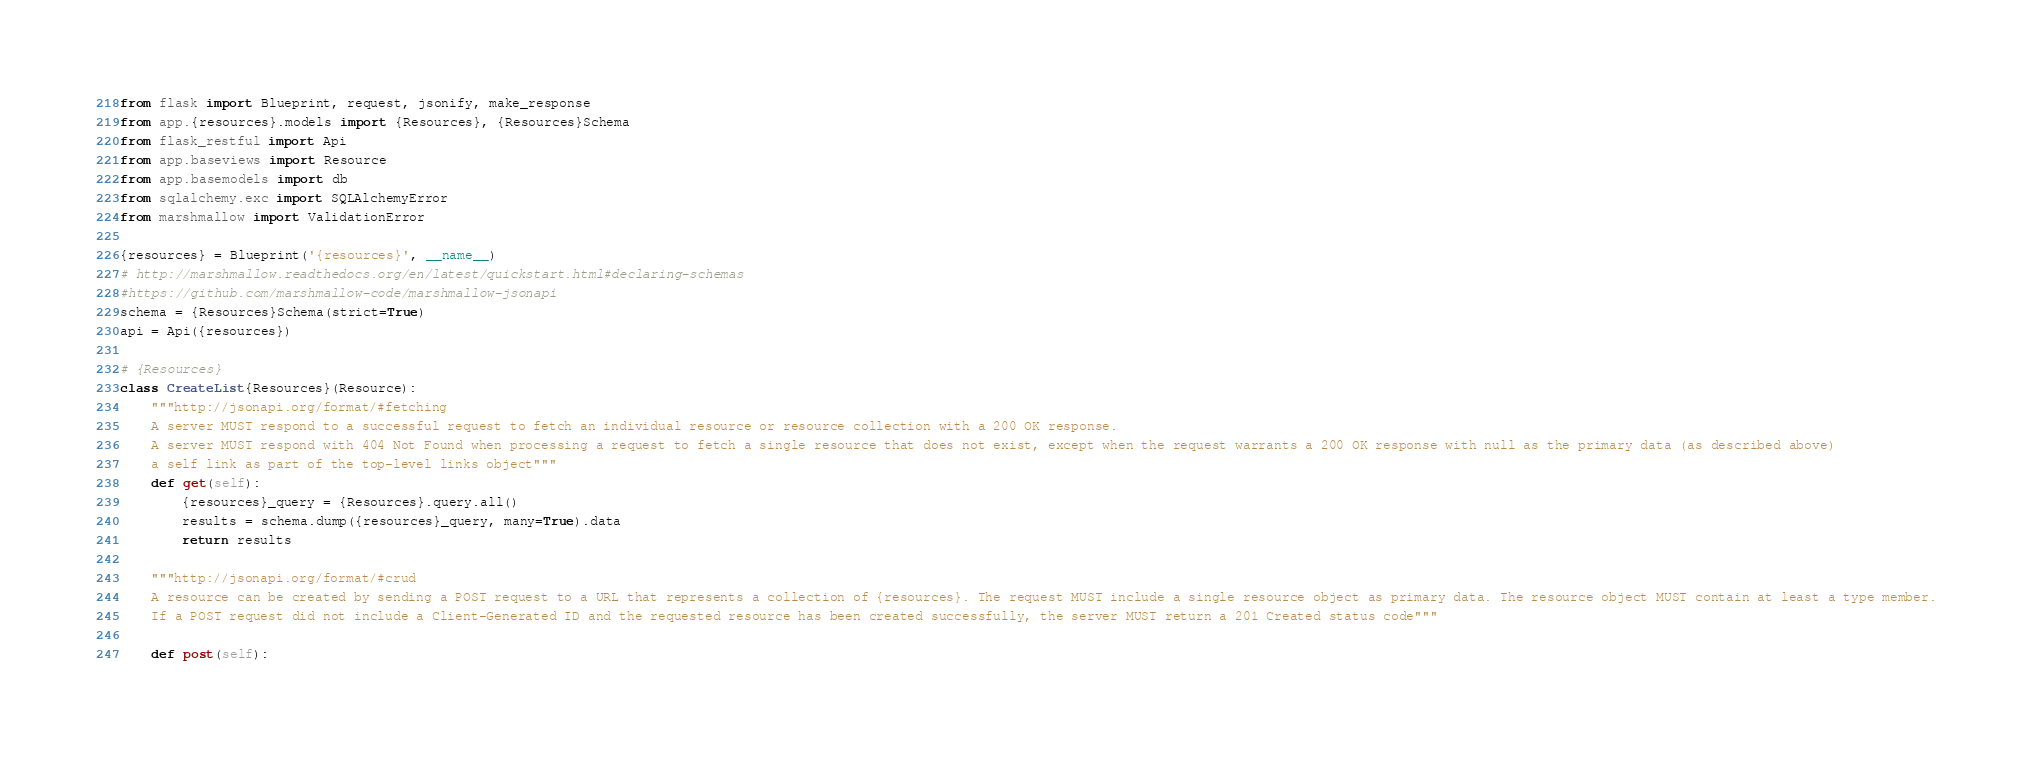Convert code to text. <code><loc_0><loc_0><loc_500><loc_500><_Python_>from flask import Blueprint, request, jsonify, make_response
from app.{resources}.models import {Resources}, {Resources}Schema
from flask_restful import Api
from app.baseviews import Resource
from app.basemodels import db
from sqlalchemy.exc import SQLAlchemyError
from marshmallow import ValidationError

{resources} = Blueprint('{resources}', __name__)
# http://marshmallow.readthedocs.org/en/latest/quickstart.html#declaring-schemas
#https://github.com/marshmallow-code/marshmallow-jsonapi
schema = {Resources}Schema(strict=True)
api = Api({resources})

# {Resources}
class CreateList{Resources}(Resource):
    """http://jsonapi.org/format/#fetching
    A server MUST respond to a successful request to fetch an individual resource or resource collection with a 200 OK response.
    A server MUST respond with 404 Not Found when processing a request to fetch a single resource that does not exist, except when the request warrants a 200 OK response with null as the primary data (as described above)
    a self link as part of the top-level links object"""
    def get(self):
        {resources}_query = {Resources}.query.all()
        results = schema.dump({resources}_query, many=True).data
        return results
    
    """http://jsonapi.org/format/#crud
    A resource can be created by sending a POST request to a URL that represents a collection of {resources}. The request MUST include a single resource object as primary data. The resource object MUST contain at least a type member.
    If a POST request did not include a Client-Generated ID and the requested resource has been created successfully, the server MUST return a 201 Created status code"""
    
    def post(self):</code> 